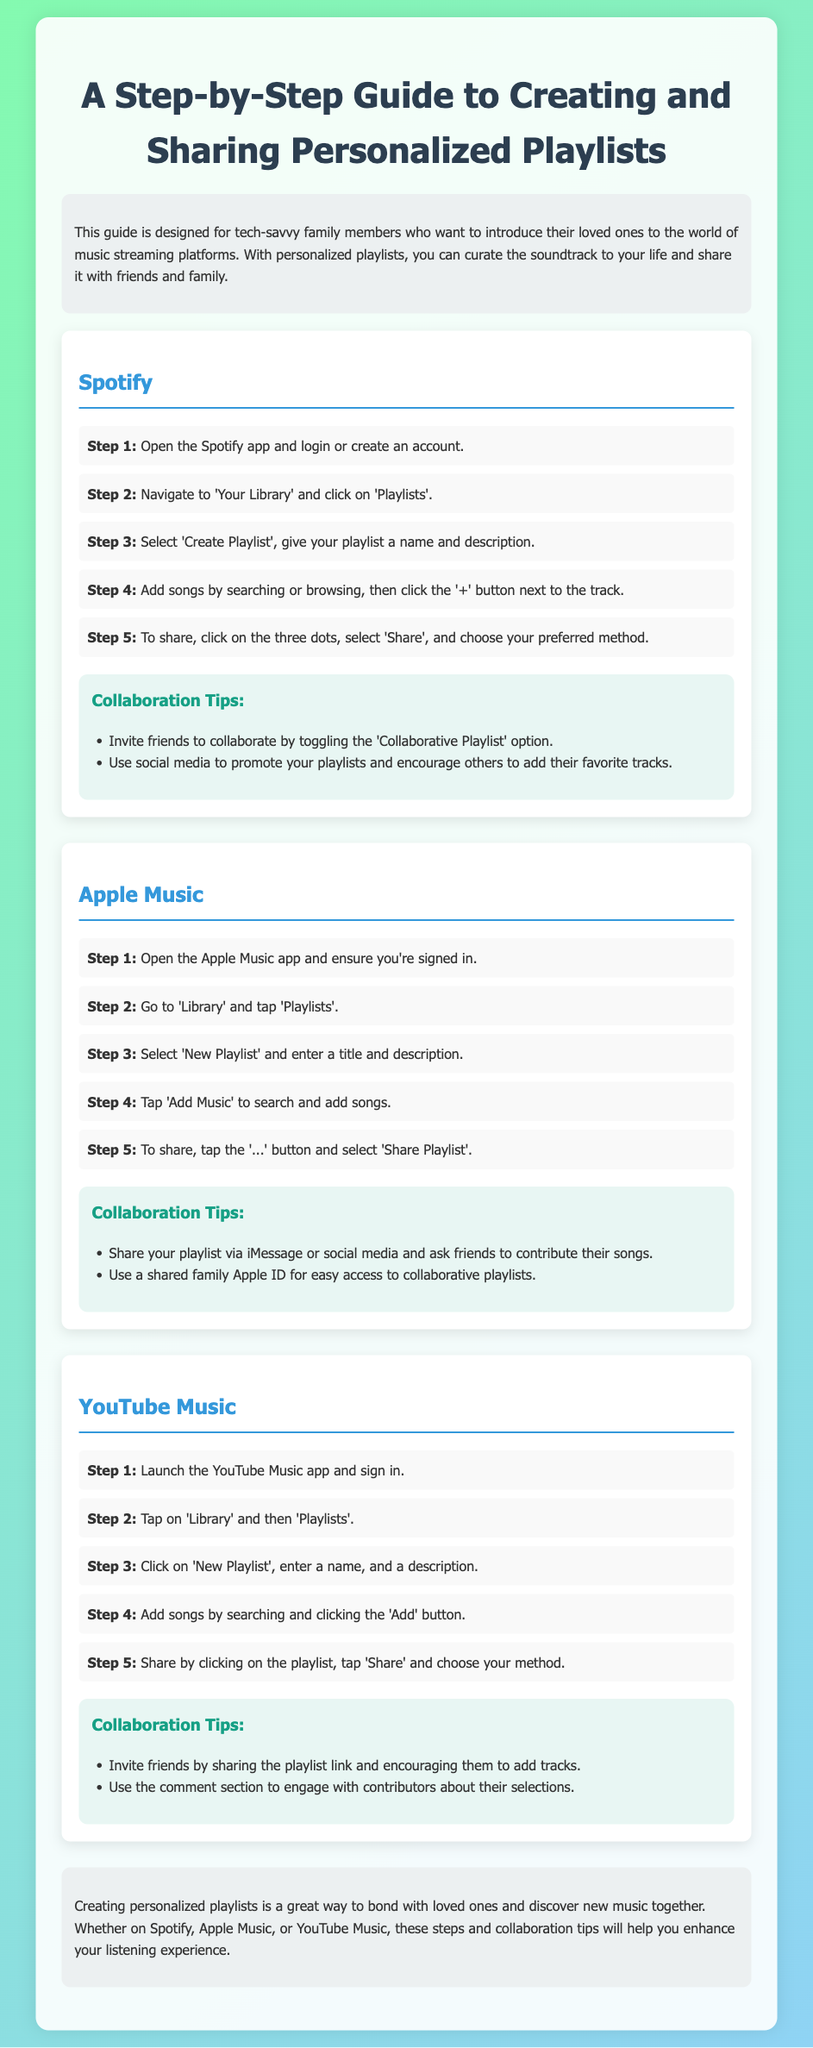What is the main purpose of this guide? The guide is designed for tech-savvy family members who want to introduce their loved ones to music streaming platforms.
Answer: Introducing music streaming platforms How many steps are listed for creating a playlist on Spotify? The document specifies five steps for creating a playlist on Spotify.
Answer: Five steps Which feature allows friends to contribute to a playlist on Spotify? The document describes a feature called 'Collaborative Playlist' that allows friends to contribute.
Answer: Collaborative Playlist What should you tap to start a new playlist in Apple Music? The guide instructs users to tap 'New Playlist' in Apple Music to start a playlist.
Answer: New Playlist Which app requires signing into an account before creating a playlist? The guide mentions that users must sign into Apple Music before creating a playlist.
Answer: Apple Music How can you share a playlist on YouTube Music? The document states that you can share a YouTube Music playlist by clicking on it and tapping 'Share'.
Answer: Click 'Share' What type of tips are provided in each streaming service section? The document provides 'Collaboration Tips' for each streaming service section.
Answer: Collaboration Tips How can you enhance your listening experience according to the conclusion? The conclusion suggests that creating personalized playlists helps in bonding and discovering new music together.
Answer: Bonding and discovering new music What is the background color scheme of the document? The document describes a background color scheme as a linear gradient from green to blue.
Answer: Linear gradient from green to blue In which section can you find steps for creating a playlist on Apple Music? The steps for creating a playlist on Apple Music are found under the service heading 'Apple Music'.
Answer: Apple Music 